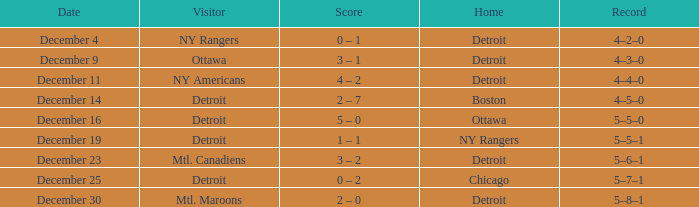What document lists detroit as the home team and mtl. maroons as the visiting team? 5–8–1. 